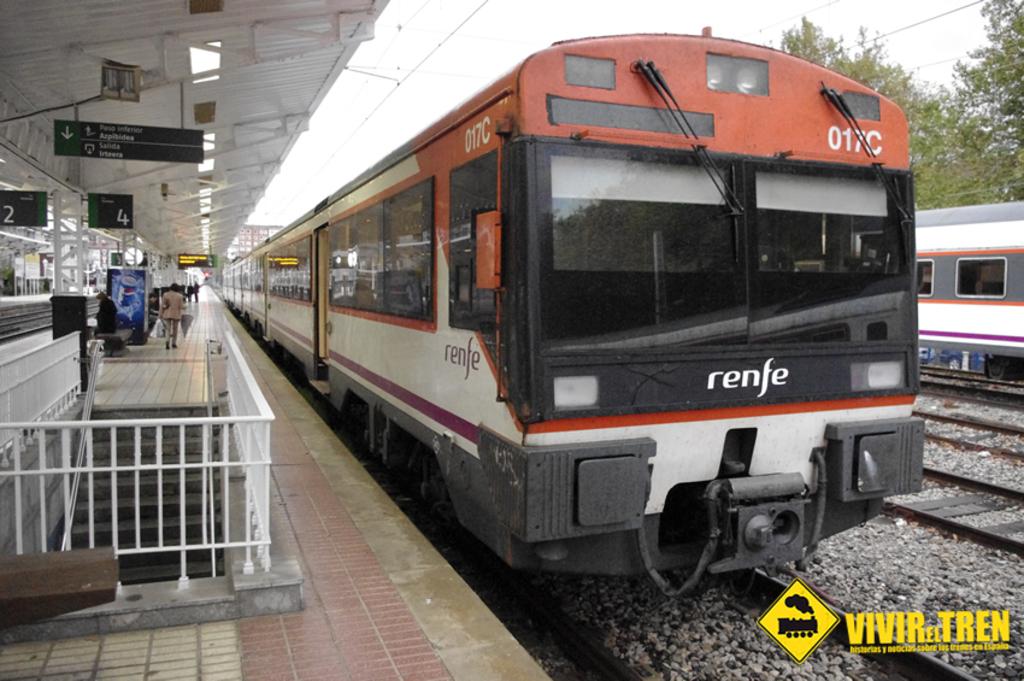What brand train is this?
Provide a short and direct response. Renfe. 